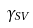<formula> <loc_0><loc_0><loc_500><loc_500>\gamma _ { S V }</formula> 